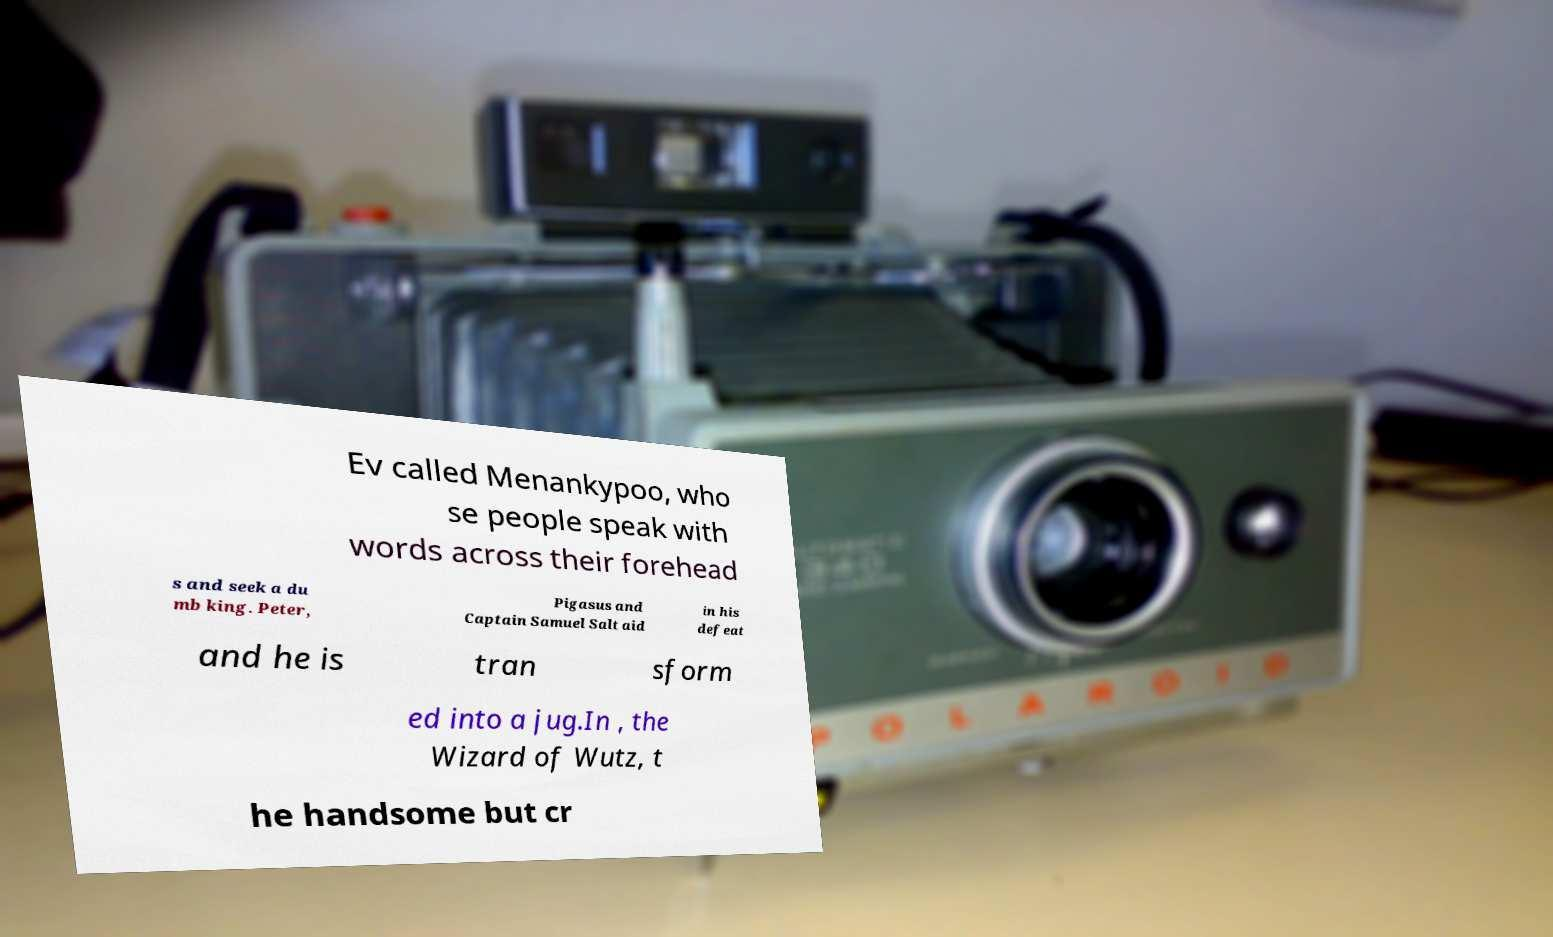There's text embedded in this image that I need extracted. Can you transcribe it verbatim? Ev called Menankypoo, who se people speak with words across their forehead s and seek a du mb king. Peter, Pigasus and Captain Samuel Salt aid in his defeat and he is tran sform ed into a jug.In , the Wizard of Wutz, t he handsome but cr 